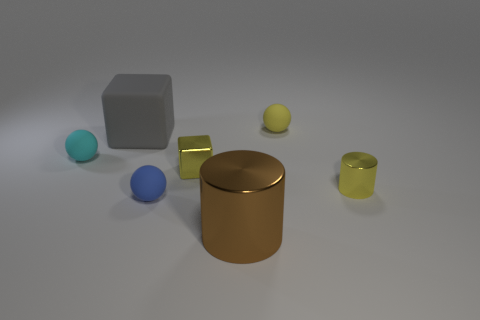How many things are either large cylinders in front of the yellow cylinder or small matte spheres to the left of the blue object?
Offer a terse response. 2. How many small yellow metallic cylinders are to the left of the small metallic object that is right of the large brown object?
Make the answer very short. 0. What is the color of the small block that is the same material as the yellow cylinder?
Your answer should be compact. Yellow. Are there any yellow metal objects of the same size as the brown cylinder?
Provide a short and direct response. No. What shape is the cyan thing that is the same size as the yellow matte thing?
Your response must be concise. Sphere. Are there any small gray matte objects of the same shape as the big brown metal thing?
Provide a succinct answer. No. Is the cyan thing made of the same material as the yellow block that is to the left of the brown thing?
Your answer should be compact. No. Are there any other blocks of the same color as the large rubber cube?
Give a very brief answer. No. How many other things are there of the same material as the brown thing?
Keep it short and to the point. 2. Do the big rubber block and the sphere on the right side of the brown metal object have the same color?
Your answer should be compact. No. 